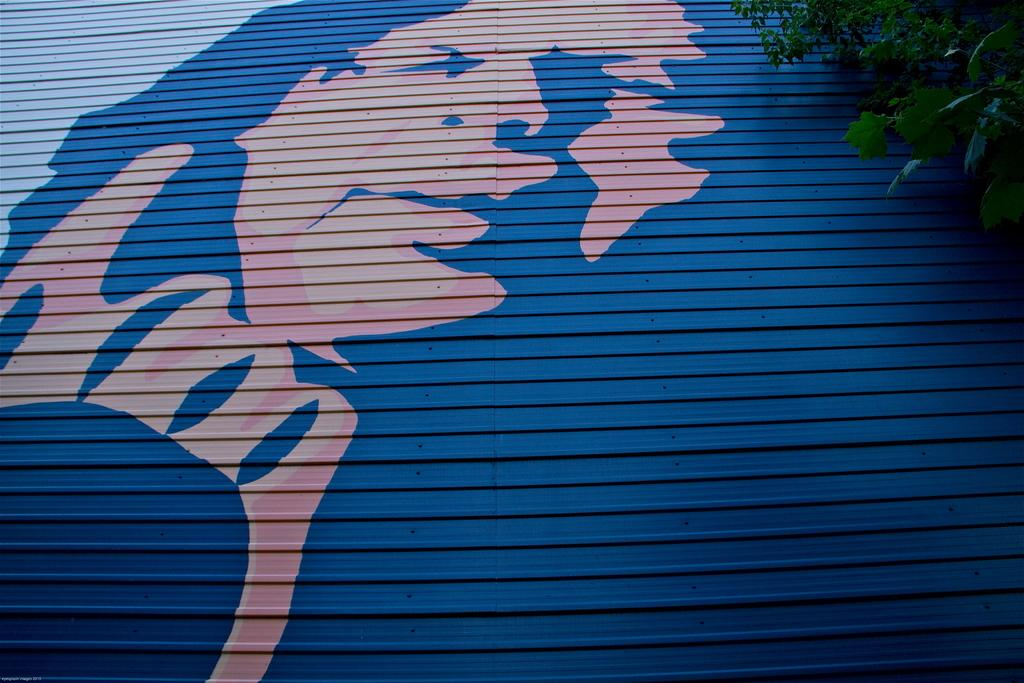What is the main subject of the image? There is a painting of a person's face in the image. What other object or element can be seen in the image? There is a tree visible in the image, to the right of the painting. What type of list can be seen hanging from the tree in the image? There is no list present in the image; it features a painting of a person's face and a tree. What type of spot can be seen on the person's face in the painting? The facts provided do not mention any spots on the person's face in the painting. 